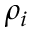Convert formula to latex. <formula><loc_0><loc_0><loc_500><loc_500>\rho _ { i }</formula> 